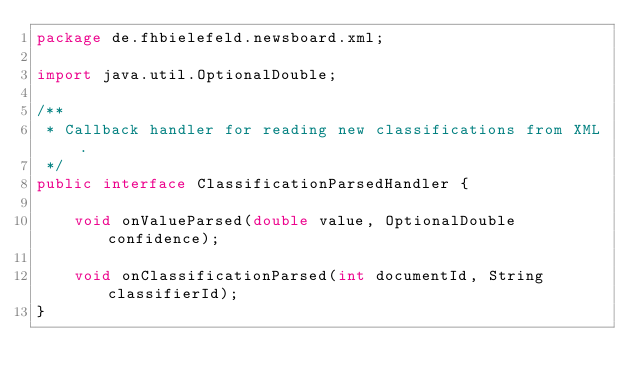Convert code to text. <code><loc_0><loc_0><loc_500><loc_500><_Java_>package de.fhbielefeld.newsboard.xml;

import java.util.OptionalDouble;

/**
 * Callback handler for reading new classifications from XML.
 */
public interface ClassificationParsedHandler {

    void onValueParsed(double value, OptionalDouble confidence);

    void onClassificationParsed(int documentId, String classifierId);
}
</code> 